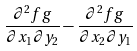Convert formula to latex. <formula><loc_0><loc_0><loc_500><loc_500>\frac { \partial ^ { 2 } f g } { \partial x _ { 1 } \partial y _ { 2 } } - \frac { \partial ^ { 2 } f g } { \partial x _ { 2 } \partial y _ { 1 } }</formula> 